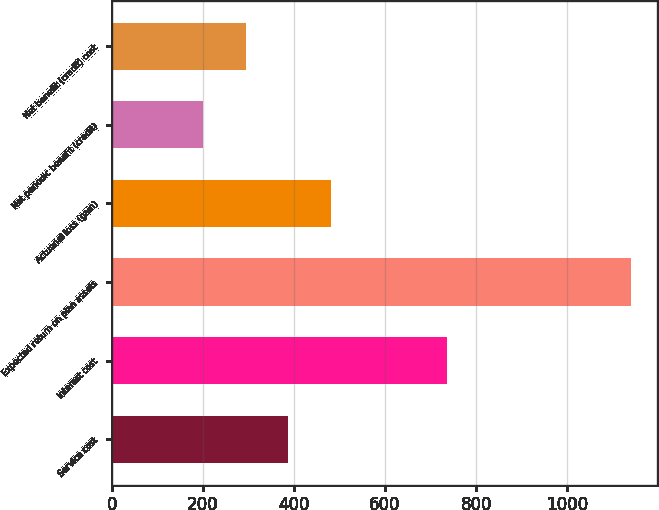Convert chart to OTSL. <chart><loc_0><loc_0><loc_500><loc_500><bar_chart><fcel>Service cost<fcel>Interest cost<fcel>Expected return on plan assets<fcel>Actuarial loss (gain)<fcel>Net periodic benefit (credit)<fcel>Net benefit (credit) cost<nl><fcel>388<fcel>737<fcel>1140<fcel>482<fcel>200<fcel>294<nl></chart> 